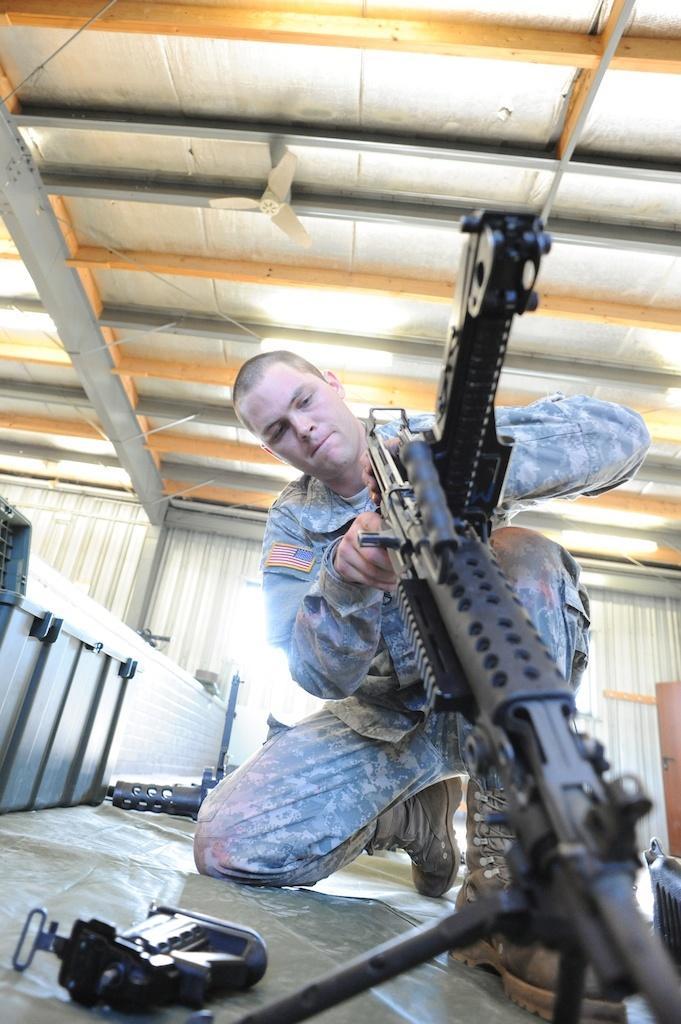How would you summarize this image in a sentence or two? In this image I can see the person wearing the military dress and holding the weapon. To the side I can see few more weapons on the floor. I can see the person is inside the shed. 